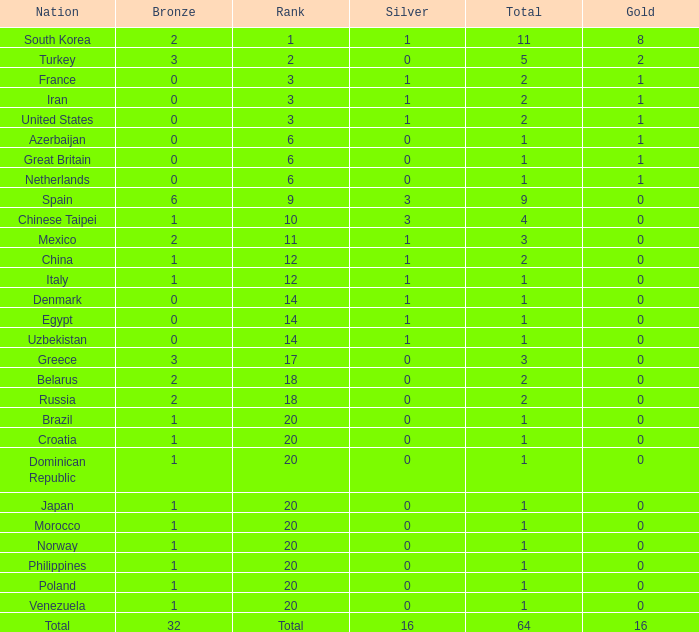What is the average number of bronze of the nation with more than 1 gold and 1 silver medal? 2.0. 